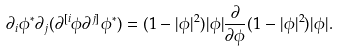<formula> <loc_0><loc_0><loc_500><loc_500>\partial _ { i } \phi ^ { * } \partial _ { j } ( \partial ^ { [ i } \phi \partial ^ { j ] } \phi ^ { * } ) = ( 1 - | \phi | ^ { 2 } ) | \phi | \frac { \partial } { \partial \phi } ( 1 - | \phi | ^ { 2 } ) | \phi | .</formula> 